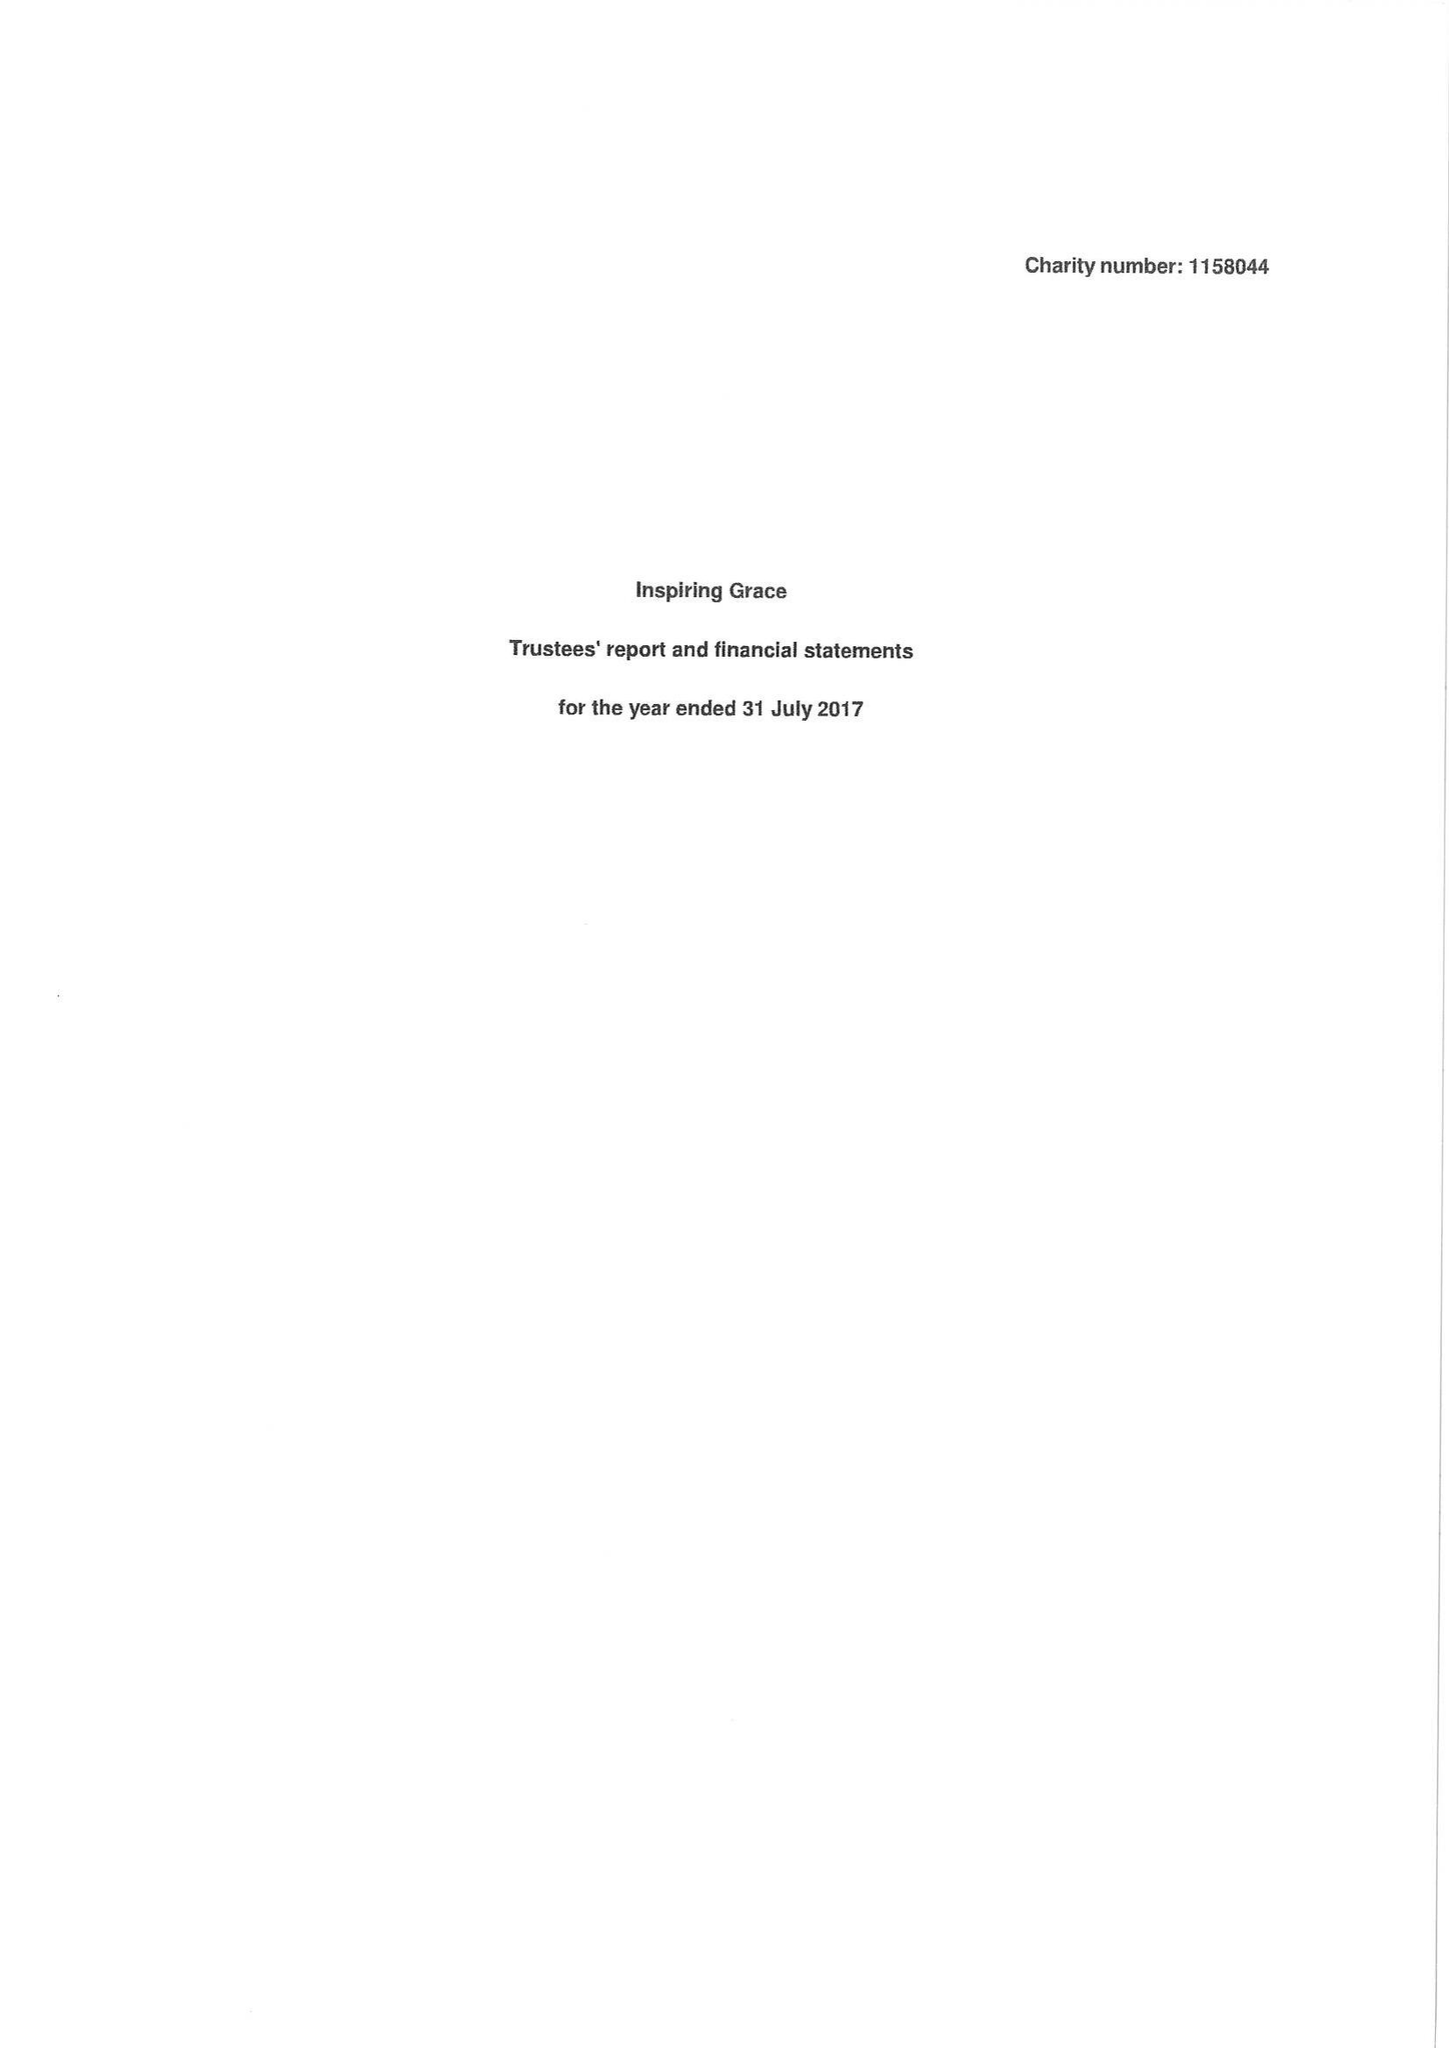What is the value for the spending_annually_in_british_pounds?
Answer the question using a single word or phrase. 51437.00 